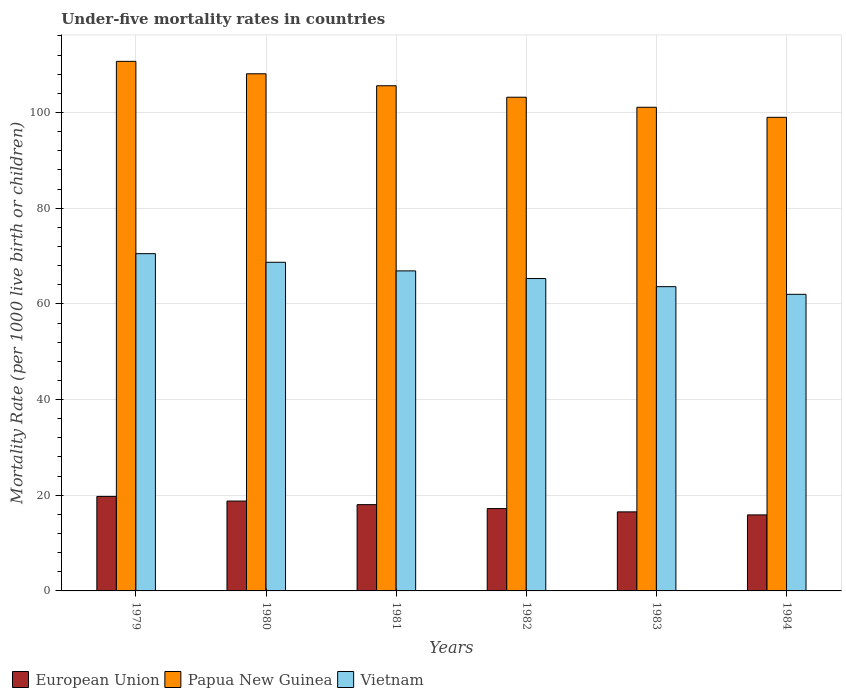Are the number of bars on each tick of the X-axis equal?
Offer a very short reply. Yes. How many bars are there on the 5th tick from the left?
Offer a terse response. 3. How many bars are there on the 1st tick from the right?
Make the answer very short. 3. What is the label of the 1st group of bars from the left?
Give a very brief answer. 1979. In how many cases, is the number of bars for a given year not equal to the number of legend labels?
Your answer should be very brief. 0. What is the under-five mortality rate in Vietnam in 1981?
Make the answer very short. 66.9. Across all years, what is the maximum under-five mortality rate in Papua New Guinea?
Make the answer very short. 110.7. In which year was the under-five mortality rate in European Union maximum?
Your response must be concise. 1979. What is the total under-five mortality rate in European Union in the graph?
Provide a succinct answer. 106.21. What is the difference between the under-five mortality rate in Papua New Guinea in 1979 and that in 1981?
Your answer should be very brief. 5.1. What is the difference between the under-five mortality rate in European Union in 1981 and the under-five mortality rate in Papua New Guinea in 1984?
Offer a terse response. -80.96. What is the average under-five mortality rate in Vietnam per year?
Provide a short and direct response. 66.17. In the year 1979, what is the difference between the under-five mortality rate in Papua New Guinea and under-five mortality rate in Vietnam?
Make the answer very short. 40.2. What is the ratio of the under-five mortality rate in Papua New Guinea in 1982 to that in 1983?
Your answer should be very brief. 1.02. Is the under-five mortality rate in Vietnam in 1983 less than that in 1984?
Your answer should be compact. No. What is the difference between the highest and the second highest under-five mortality rate in European Union?
Your answer should be compact. 0.97. What is the difference between the highest and the lowest under-five mortality rate in Vietnam?
Offer a terse response. 8.5. In how many years, is the under-five mortality rate in European Union greater than the average under-five mortality rate in European Union taken over all years?
Provide a succinct answer. 3. What does the 2nd bar from the left in 1983 represents?
Give a very brief answer. Papua New Guinea. What does the 2nd bar from the right in 1981 represents?
Make the answer very short. Papua New Guinea. How many bars are there?
Make the answer very short. 18. Are all the bars in the graph horizontal?
Your answer should be compact. No. What is the difference between two consecutive major ticks on the Y-axis?
Your response must be concise. 20. Are the values on the major ticks of Y-axis written in scientific E-notation?
Provide a short and direct response. No. Does the graph contain grids?
Ensure brevity in your answer.  Yes. Where does the legend appear in the graph?
Give a very brief answer. Bottom left. What is the title of the graph?
Keep it short and to the point. Under-five mortality rates in countries. Does "Jamaica" appear as one of the legend labels in the graph?
Make the answer very short. No. What is the label or title of the X-axis?
Give a very brief answer. Years. What is the label or title of the Y-axis?
Give a very brief answer. Mortality Rate (per 1000 live birth or children). What is the Mortality Rate (per 1000 live birth or children) in European Union in 1979?
Your response must be concise. 19.76. What is the Mortality Rate (per 1000 live birth or children) in Papua New Guinea in 1979?
Ensure brevity in your answer.  110.7. What is the Mortality Rate (per 1000 live birth or children) in Vietnam in 1979?
Your answer should be very brief. 70.5. What is the Mortality Rate (per 1000 live birth or children) of European Union in 1980?
Keep it short and to the point. 18.78. What is the Mortality Rate (per 1000 live birth or children) in Papua New Guinea in 1980?
Offer a terse response. 108.1. What is the Mortality Rate (per 1000 live birth or children) in Vietnam in 1980?
Keep it short and to the point. 68.7. What is the Mortality Rate (per 1000 live birth or children) in European Union in 1981?
Your answer should be compact. 18.04. What is the Mortality Rate (per 1000 live birth or children) of Papua New Guinea in 1981?
Give a very brief answer. 105.6. What is the Mortality Rate (per 1000 live birth or children) of Vietnam in 1981?
Your answer should be very brief. 66.9. What is the Mortality Rate (per 1000 live birth or children) of European Union in 1982?
Provide a succinct answer. 17.21. What is the Mortality Rate (per 1000 live birth or children) of Papua New Guinea in 1982?
Give a very brief answer. 103.2. What is the Mortality Rate (per 1000 live birth or children) in Vietnam in 1982?
Your answer should be very brief. 65.3. What is the Mortality Rate (per 1000 live birth or children) in European Union in 1983?
Make the answer very short. 16.53. What is the Mortality Rate (per 1000 live birth or children) in Papua New Guinea in 1983?
Ensure brevity in your answer.  101.1. What is the Mortality Rate (per 1000 live birth or children) in Vietnam in 1983?
Give a very brief answer. 63.6. What is the Mortality Rate (per 1000 live birth or children) of European Union in 1984?
Provide a short and direct response. 15.89. Across all years, what is the maximum Mortality Rate (per 1000 live birth or children) in European Union?
Keep it short and to the point. 19.76. Across all years, what is the maximum Mortality Rate (per 1000 live birth or children) in Papua New Guinea?
Keep it short and to the point. 110.7. Across all years, what is the maximum Mortality Rate (per 1000 live birth or children) of Vietnam?
Make the answer very short. 70.5. Across all years, what is the minimum Mortality Rate (per 1000 live birth or children) of European Union?
Your answer should be very brief. 15.89. Across all years, what is the minimum Mortality Rate (per 1000 live birth or children) of Papua New Guinea?
Give a very brief answer. 99. What is the total Mortality Rate (per 1000 live birth or children) in European Union in the graph?
Your answer should be compact. 106.21. What is the total Mortality Rate (per 1000 live birth or children) of Papua New Guinea in the graph?
Offer a terse response. 627.7. What is the total Mortality Rate (per 1000 live birth or children) of Vietnam in the graph?
Give a very brief answer. 397. What is the difference between the Mortality Rate (per 1000 live birth or children) in European Union in 1979 and that in 1980?
Offer a very short reply. 0.97. What is the difference between the Mortality Rate (per 1000 live birth or children) in European Union in 1979 and that in 1981?
Offer a very short reply. 1.72. What is the difference between the Mortality Rate (per 1000 live birth or children) of Papua New Guinea in 1979 and that in 1981?
Offer a terse response. 5.1. What is the difference between the Mortality Rate (per 1000 live birth or children) in European Union in 1979 and that in 1982?
Give a very brief answer. 2.54. What is the difference between the Mortality Rate (per 1000 live birth or children) of Papua New Guinea in 1979 and that in 1982?
Ensure brevity in your answer.  7.5. What is the difference between the Mortality Rate (per 1000 live birth or children) of Vietnam in 1979 and that in 1982?
Provide a succinct answer. 5.2. What is the difference between the Mortality Rate (per 1000 live birth or children) of European Union in 1979 and that in 1983?
Give a very brief answer. 3.23. What is the difference between the Mortality Rate (per 1000 live birth or children) of European Union in 1979 and that in 1984?
Give a very brief answer. 3.86. What is the difference between the Mortality Rate (per 1000 live birth or children) of Papua New Guinea in 1979 and that in 1984?
Offer a very short reply. 11.7. What is the difference between the Mortality Rate (per 1000 live birth or children) of European Union in 1980 and that in 1981?
Give a very brief answer. 0.75. What is the difference between the Mortality Rate (per 1000 live birth or children) in European Union in 1980 and that in 1982?
Offer a terse response. 1.57. What is the difference between the Mortality Rate (per 1000 live birth or children) of Papua New Guinea in 1980 and that in 1982?
Your answer should be compact. 4.9. What is the difference between the Mortality Rate (per 1000 live birth or children) in European Union in 1980 and that in 1983?
Offer a terse response. 2.26. What is the difference between the Mortality Rate (per 1000 live birth or children) in Vietnam in 1980 and that in 1983?
Provide a short and direct response. 5.1. What is the difference between the Mortality Rate (per 1000 live birth or children) of European Union in 1980 and that in 1984?
Your response must be concise. 2.89. What is the difference between the Mortality Rate (per 1000 live birth or children) in Papua New Guinea in 1980 and that in 1984?
Your answer should be compact. 9.1. What is the difference between the Mortality Rate (per 1000 live birth or children) in European Union in 1981 and that in 1982?
Your answer should be compact. 0.83. What is the difference between the Mortality Rate (per 1000 live birth or children) in European Union in 1981 and that in 1983?
Give a very brief answer. 1.51. What is the difference between the Mortality Rate (per 1000 live birth or children) of Vietnam in 1981 and that in 1983?
Ensure brevity in your answer.  3.3. What is the difference between the Mortality Rate (per 1000 live birth or children) of European Union in 1981 and that in 1984?
Ensure brevity in your answer.  2.15. What is the difference between the Mortality Rate (per 1000 live birth or children) in Papua New Guinea in 1981 and that in 1984?
Offer a terse response. 6.6. What is the difference between the Mortality Rate (per 1000 live birth or children) in European Union in 1982 and that in 1983?
Offer a terse response. 0.69. What is the difference between the Mortality Rate (per 1000 live birth or children) of European Union in 1982 and that in 1984?
Your answer should be compact. 1.32. What is the difference between the Mortality Rate (per 1000 live birth or children) of Papua New Guinea in 1982 and that in 1984?
Your answer should be very brief. 4.2. What is the difference between the Mortality Rate (per 1000 live birth or children) in Vietnam in 1982 and that in 1984?
Provide a succinct answer. 3.3. What is the difference between the Mortality Rate (per 1000 live birth or children) of European Union in 1983 and that in 1984?
Offer a terse response. 0.64. What is the difference between the Mortality Rate (per 1000 live birth or children) in Papua New Guinea in 1983 and that in 1984?
Your answer should be very brief. 2.1. What is the difference between the Mortality Rate (per 1000 live birth or children) in European Union in 1979 and the Mortality Rate (per 1000 live birth or children) in Papua New Guinea in 1980?
Make the answer very short. -88.34. What is the difference between the Mortality Rate (per 1000 live birth or children) of European Union in 1979 and the Mortality Rate (per 1000 live birth or children) of Vietnam in 1980?
Make the answer very short. -48.94. What is the difference between the Mortality Rate (per 1000 live birth or children) of European Union in 1979 and the Mortality Rate (per 1000 live birth or children) of Papua New Guinea in 1981?
Make the answer very short. -85.84. What is the difference between the Mortality Rate (per 1000 live birth or children) of European Union in 1979 and the Mortality Rate (per 1000 live birth or children) of Vietnam in 1981?
Your response must be concise. -47.14. What is the difference between the Mortality Rate (per 1000 live birth or children) in Papua New Guinea in 1979 and the Mortality Rate (per 1000 live birth or children) in Vietnam in 1981?
Provide a succinct answer. 43.8. What is the difference between the Mortality Rate (per 1000 live birth or children) of European Union in 1979 and the Mortality Rate (per 1000 live birth or children) of Papua New Guinea in 1982?
Your response must be concise. -83.44. What is the difference between the Mortality Rate (per 1000 live birth or children) in European Union in 1979 and the Mortality Rate (per 1000 live birth or children) in Vietnam in 1982?
Offer a very short reply. -45.54. What is the difference between the Mortality Rate (per 1000 live birth or children) of Papua New Guinea in 1979 and the Mortality Rate (per 1000 live birth or children) of Vietnam in 1982?
Offer a very short reply. 45.4. What is the difference between the Mortality Rate (per 1000 live birth or children) of European Union in 1979 and the Mortality Rate (per 1000 live birth or children) of Papua New Guinea in 1983?
Give a very brief answer. -81.34. What is the difference between the Mortality Rate (per 1000 live birth or children) of European Union in 1979 and the Mortality Rate (per 1000 live birth or children) of Vietnam in 1983?
Your answer should be compact. -43.84. What is the difference between the Mortality Rate (per 1000 live birth or children) of Papua New Guinea in 1979 and the Mortality Rate (per 1000 live birth or children) of Vietnam in 1983?
Provide a succinct answer. 47.1. What is the difference between the Mortality Rate (per 1000 live birth or children) of European Union in 1979 and the Mortality Rate (per 1000 live birth or children) of Papua New Guinea in 1984?
Provide a short and direct response. -79.24. What is the difference between the Mortality Rate (per 1000 live birth or children) of European Union in 1979 and the Mortality Rate (per 1000 live birth or children) of Vietnam in 1984?
Your answer should be very brief. -42.24. What is the difference between the Mortality Rate (per 1000 live birth or children) of Papua New Guinea in 1979 and the Mortality Rate (per 1000 live birth or children) of Vietnam in 1984?
Provide a short and direct response. 48.7. What is the difference between the Mortality Rate (per 1000 live birth or children) in European Union in 1980 and the Mortality Rate (per 1000 live birth or children) in Papua New Guinea in 1981?
Your answer should be very brief. -86.82. What is the difference between the Mortality Rate (per 1000 live birth or children) of European Union in 1980 and the Mortality Rate (per 1000 live birth or children) of Vietnam in 1981?
Your answer should be very brief. -48.12. What is the difference between the Mortality Rate (per 1000 live birth or children) of Papua New Guinea in 1980 and the Mortality Rate (per 1000 live birth or children) of Vietnam in 1981?
Your response must be concise. 41.2. What is the difference between the Mortality Rate (per 1000 live birth or children) of European Union in 1980 and the Mortality Rate (per 1000 live birth or children) of Papua New Guinea in 1982?
Your answer should be compact. -84.42. What is the difference between the Mortality Rate (per 1000 live birth or children) in European Union in 1980 and the Mortality Rate (per 1000 live birth or children) in Vietnam in 1982?
Offer a very short reply. -46.52. What is the difference between the Mortality Rate (per 1000 live birth or children) of Papua New Guinea in 1980 and the Mortality Rate (per 1000 live birth or children) of Vietnam in 1982?
Offer a terse response. 42.8. What is the difference between the Mortality Rate (per 1000 live birth or children) in European Union in 1980 and the Mortality Rate (per 1000 live birth or children) in Papua New Guinea in 1983?
Make the answer very short. -82.32. What is the difference between the Mortality Rate (per 1000 live birth or children) of European Union in 1980 and the Mortality Rate (per 1000 live birth or children) of Vietnam in 1983?
Give a very brief answer. -44.82. What is the difference between the Mortality Rate (per 1000 live birth or children) in Papua New Guinea in 1980 and the Mortality Rate (per 1000 live birth or children) in Vietnam in 1983?
Make the answer very short. 44.5. What is the difference between the Mortality Rate (per 1000 live birth or children) of European Union in 1980 and the Mortality Rate (per 1000 live birth or children) of Papua New Guinea in 1984?
Offer a very short reply. -80.22. What is the difference between the Mortality Rate (per 1000 live birth or children) of European Union in 1980 and the Mortality Rate (per 1000 live birth or children) of Vietnam in 1984?
Provide a succinct answer. -43.22. What is the difference between the Mortality Rate (per 1000 live birth or children) in Papua New Guinea in 1980 and the Mortality Rate (per 1000 live birth or children) in Vietnam in 1984?
Provide a short and direct response. 46.1. What is the difference between the Mortality Rate (per 1000 live birth or children) in European Union in 1981 and the Mortality Rate (per 1000 live birth or children) in Papua New Guinea in 1982?
Your answer should be compact. -85.16. What is the difference between the Mortality Rate (per 1000 live birth or children) of European Union in 1981 and the Mortality Rate (per 1000 live birth or children) of Vietnam in 1982?
Your answer should be compact. -47.26. What is the difference between the Mortality Rate (per 1000 live birth or children) of Papua New Guinea in 1981 and the Mortality Rate (per 1000 live birth or children) of Vietnam in 1982?
Provide a short and direct response. 40.3. What is the difference between the Mortality Rate (per 1000 live birth or children) in European Union in 1981 and the Mortality Rate (per 1000 live birth or children) in Papua New Guinea in 1983?
Make the answer very short. -83.06. What is the difference between the Mortality Rate (per 1000 live birth or children) in European Union in 1981 and the Mortality Rate (per 1000 live birth or children) in Vietnam in 1983?
Your answer should be compact. -45.56. What is the difference between the Mortality Rate (per 1000 live birth or children) in Papua New Guinea in 1981 and the Mortality Rate (per 1000 live birth or children) in Vietnam in 1983?
Your answer should be compact. 42. What is the difference between the Mortality Rate (per 1000 live birth or children) in European Union in 1981 and the Mortality Rate (per 1000 live birth or children) in Papua New Guinea in 1984?
Provide a succinct answer. -80.96. What is the difference between the Mortality Rate (per 1000 live birth or children) of European Union in 1981 and the Mortality Rate (per 1000 live birth or children) of Vietnam in 1984?
Give a very brief answer. -43.96. What is the difference between the Mortality Rate (per 1000 live birth or children) in Papua New Guinea in 1981 and the Mortality Rate (per 1000 live birth or children) in Vietnam in 1984?
Ensure brevity in your answer.  43.6. What is the difference between the Mortality Rate (per 1000 live birth or children) in European Union in 1982 and the Mortality Rate (per 1000 live birth or children) in Papua New Guinea in 1983?
Your answer should be very brief. -83.89. What is the difference between the Mortality Rate (per 1000 live birth or children) in European Union in 1982 and the Mortality Rate (per 1000 live birth or children) in Vietnam in 1983?
Offer a very short reply. -46.39. What is the difference between the Mortality Rate (per 1000 live birth or children) of Papua New Guinea in 1982 and the Mortality Rate (per 1000 live birth or children) of Vietnam in 1983?
Keep it short and to the point. 39.6. What is the difference between the Mortality Rate (per 1000 live birth or children) in European Union in 1982 and the Mortality Rate (per 1000 live birth or children) in Papua New Guinea in 1984?
Provide a succinct answer. -81.79. What is the difference between the Mortality Rate (per 1000 live birth or children) in European Union in 1982 and the Mortality Rate (per 1000 live birth or children) in Vietnam in 1984?
Offer a very short reply. -44.79. What is the difference between the Mortality Rate (per 1000 live birth or children) in Papua New Guinea in 1982 and the Mortality Rate (per 1000 live birth or children) in Vietnam in 1984?
Offer a very short reply. 41.2. What is the difference between the Mortality Rate (per 1000 live birth or children) in European Union in 1983 and the Mortality Rate (per 1000 live birth or children) in Papua New Guinea in 1984?
Give a very brief answer. -82.47. What is the difference between the Mortality Rate (per 1000 live birth or children) of European Union in 1983 and the Mortality Rate (per 1000 live birth or children) of Vietnam in 1984?
Make the answer very short. -45.47. What is the difference between the Mortality Rate (per 1000 live birth or children) in Papua New Guinea in 1983 and the Mortality Rate (per 1000 live birth or children) in Vietnam in 1984?
Your answer should be very brief. 39.1. What is the average Mortality Rate (per 1000 live birth or children) in European Union per year?
Provide a short and direct response. 17.7. What is the average Mortality Rate (per 1000 live birth or children) of Papua New Guinea per year?
Offer a very short reply. 104.62. What is the average Mortality Rate (per 1000 live birth or children) of Vietnam per year?
Your answer should be compact. 66.17. In the year 1979, what is the difference between the Mortality Rate (per 1000 live birth or children) in European Union and Mortality Rate (per 1000 live birth or children) in Papua New Guinea?
Make the answer very short. -90.94. In the year 1979, what is the difference between the Mortality Rate (per 1000 live birth or children) in European Union and Mortality Rate (per 1000 live birth or children) in Vietnam?
Give a very brief answer. -50.74. In the year 1979, what is the difference between the Mortality Rate (per 1000 live birth or children) of Papua New Guinea and Mortality Rate (per 1000 live birth or children) of Vietnam?
Make the answer very short. 40.2. In the year 1980, what is the difference between the Mortality Rate (per 1000 live birth or children) in European Union and Mortality Rate (per 1000 live birth or children) in Papua New Guinea?
Provide a short and direct response. -89.32. In the year 1980, what is the difference between the Mortality Rate (per 1000 live birth or children) in European Union and Mortality Rate (per 1000 live birth or children) in Vietnam?
Keep it short and to the point. -49.92. In the year 1980, what is the difference between the Mortality Rate (per 1000 live birth or children) of Papua New Guinea and Mortality Rate (per 1000 live birth or children) of Vietnam?
Your answer should be very brief. 39.4. In the year 1981, what is the difference between the Mortality Rate (per 1000 live birth or children) in European Union and Mortality Rate (per 1000 live birth or children) in Papua New Guinea?
Offer a terse response. -87.56. In the year 1981, what is the difference between the Mortality Rate (per 1000 live birth or children) in European Union and Mortality Rate (per 1000 live birth or children) in Vietnam?
Make the answer very short. -48.86. In the year 1981, what is the difference between the Mortality Rate (per 1000 live birth or children) of Papua New Guinea and Mortality Rate (per 1000 live birth or children) of Vietnam?
Provide a short and direct response. 38.7. In the year 1982, what is the difference between the Mortality Rate (per 1000 live birth or children) in European Union and Mortality Rate (per 1000 live birth or children) in Papua New Guinea?
Your answer should be compact. -85.99. In the year 1982, what is the difference between the Mortality Rate (per 1000 live birth or children) in European Union and Mortality Rate (per 1000 live birth or children) in Vietnam?
Provide a short and direct response. -48.09. In the year 1982, what is the difference between the Mortality Rate (per 1000 live birth or children) in Papua New Guinea and Mortality Rate (per 1000 live birth or children) in Vietnam?
Keep it short and to the point. 37.9. In the year 1983, what is the difference between the Mortality Rate (per 1000 live birth or children) in European Union and Mortality Rate (per 1000 live birth or children) in Papua New Guinea?
Offer a very short reply. -84.57. In the year 1983, what is the difference between the Mortality Rate (per 1000 live birth or children) of European Union and Mortality Rate (per 1000 live birth or children) of Vietnam?
Keep it short and to the point. -47.07. In the year 1983, what is the difference between the Mortality Rate (per 1000 live birth or children) of Papua New Guinea and Mortality Rate (per 1000 live birth or children) of Vietnam?
Your answer should be compact. 37.5. In the year 1984, what is the difference between the Mortality Rate (per 1000 live birth or children) in European Union and Mortality Rate (per 1000 live birth or children) in Papua New Guinea?
Keep it short and to the point. -83.11. In the year 1984, what is the difference between the Mortality Rate (per 1000 live birth or children) in European Union and Mortality Rate (per 1000 live birth or children) in Vietnam?
Ensure brevity in your answer.  -46.11. What is the ratio of the Mortality Rate (per 1000 live birth or children) in European Union in 1979 to that in 1980?
Provide a short and direct response. 1.05. What is the ratio of the Mortality Rate (per 1000 live birth or children) in Papua New Guinea in 1979 to that in 1980?
Your response must be concise. 1.02. What is the ratio of the Mortality Rate (per 1000 live birth or children) of Vietnam in 1979 to that in 1980?
Make the answer very short. 1.03. What is the ratio of the Mortality Rate (per 1000 live birth or children) of European Union in 1979 to that in 1981?
Offer a very short reply. 1.1. What is the ratio of the Mortality Rate (per 1000 live birth or children) in Papua New Guinea in 1979 to that in 1981?
Ensure brevity in your answer.  1.05. What is the ratio of the Mortality Rate (per 1000 live birth or children) in Vietnam in 1979 to that in 1981?
Your response must be concise. 1.05. What is the ratio of the Mortality Rate (per 1000 live birth or children) of European Union in 1979 to that in 1982?
Offer a terse response. 1.15. What is the ratio of the Mortality Rate (per 1000 live birth or children) in Papua New Guinea in 1979 to that in 1982?
Provide a short and direct response. 1.07. What is the ratio of the Mortality Rate (per 1000 live birth or children) in Vietnam in 1979 to that in 1982?
Keep it short and to the point. 1.08. What is the ratio of the Mortality Rate (per 1000 live birth or children) in European Union in 1979 to that in 1983?
Your answer should be very brief. 1.2. What is the ratio of the Mortality Rate (per 1000 live birth or children) of Papua New Guinea in 1979 to that in 1983?
Provide a short and direct response. 1.09. What is the ratio of the Mortality Rate (per 1000 live birth or children) in Vietnam in 1979 to that in 1983?
Offer a terse response. 1.11. What is the ratio of the Mortality Rate (per 1000 live birth or children) in European Union in 1979 to that in 1984?
Give a very brief answer. 1.24. What is the ratio of the Mortality Rate (per 1000 live birth or children) in Papua New Guinea in 1979 to that in 1984?
Offer a very short reply. 1.12. What is the ratio of the Mortality Rate (per 1000 live birth or children) of Vietnam in 1979 to that in 1984?
Your response must be concise. 1.14. What is the ratio of the Mortality Rate (per 1000 live birth or children) in European Union in 1980 to that in 1981?
Your answer should be very brief. 1.04. What is the ratio of the Mortality Rate (per 1000 live birth or children) of Papua New Guinea in 1980 to that in 1981?
Your answer should be very brief. 1.02. What is the ratio of the Mortality Rate (per 1000 live birth or children) in Vietnam in 1980 to that in 1981?
Give a very brief answer. 1.03. What is the ratio of the Mortality Rate (per 1000 live birth or children) of European Union in 1980 to that in 1982?
Ensure brevity in your answer.  1.09. What is the ratio of the Mortality Rate (per 1000 live birth or children) in Papua New Guinea in 1980 to that in 1982?
Provide a short and direct response. 1.05. What is the ratio of the Mortality Rate (per 1000 live birth or children) in Vietnam in 1980 to that in 1982?
Offer a terse response. 1.05. What is the ratio of the Mortality Rate (per 1000 live birth or children) in European Union in 1980 to that in 1983?
Your answer should be compact. 1.14. What is the ratio of the Mortality Rate (per 1000 live birth or children) of Papua New Guinea in 1980 to that in 1983?
Give a very brief answer. 1.07. What is the ratio of the Mortality Rate (per 1000 live birth or children) of Vietnam in 1980 to that in 1983?
Make the answer very short. 1.08. What is the ratio of the Mortality Rate (per 1000 live birth or children) in European Union in 1980 to that in 1984?
Your response must be concise. 1.18. What is the ratio of the Mortality Rate (per 1000 live birth or children) of Papua New Guinea in 1980 to that in 1984?
Your answer should be very brief. 1.09. What is the ratio of the Mortality Rate (per 1000 live birth or children) in Vietnam in 1980 to that in 1984?
Keep it short and to the point. 1.11. What is the ratio of the Mortality Rate (per 1000 live birth or children) in European Union in 1981 to that in 1982?
Your answer should be very brief. 1.05. What is the ratio of the Mortality Rate (per 1000 live birth or children) in Papua New Guinea in 1981 to that in 1982?
Provide a short and direct response. 1.02. What is the ratio of the Mortality Rate (per 1000 live birth or children) of Vietnam in 1981 to that in 1982?
Your response must be concise. 1.02. What is the ratio of the Mortality Rate (per 1000 live birth or children) of European Union in 1981 to that in 1983?
Ensure brevity in your answer.  1.09. What is the ratio of the Mortality Rate (per 1000 live birth or children) in Papua New Guinea in 1981 to that in 1983?
Ensure brevity in your answer.  1.04. What is the ratio of the Mortality Rate (per 1000 live birth or children) of Vietnam in 1981 to that in 1983?
Your answer should be very brief. 1.05. What is the ratio of the Mortality Rate (per 1000 live birth or children) of European Union in 1981 to that in 1984?
Give a very brief answer. 1.14. What is the ratio of the Mortality Rate (per 1000 live birth or children) of Papua New Guinea in 1981 to that in 1984?
Ensure brevity in your answer.  1.07. What is the ratio of the Mortality Rate (per 1000 live birth or children) of Vietnam in 1981 to that in 1984?
Offer a terse response. 1.08. What is the ratio of the Mortality Rate (per 1000 live birth or children) in European Union in 1982 to that in 1983?
Your answer should be compact. 1.04. What is the ratio of the Mortality Rate (per 1000 live birth or children) of Papua New Guinea in 1982 to that in 1983?
Your answer should be very brief. 1.02. What is the ratio of the Mortality Rate (per 1000 live birth or children) in Vietnam in 1982 to that in 1983?
Your answer should be very brief. 1.03. What is the ratio of the Mortality Rate (per 1000 live birth or children) in European Union in 1982 to that in 1984?
Offer a very short reply. 1.08. What is the ratio of the Mortality Rate (per 1000 live birth or children) in Papua New Guinea in 1982 to that in 1984?
Your answer should be compact. 1.04. What is the ratio of the Mortality Rate (per 1000 live birth or children) of Vietnam in 1982 to that in 1984?
Ensure brevity in your answer.  1.05. What is the ratio of the Mortality Rate (per 1000 live birth or children) in European Union in 1983 to that in 1984?
Make the answer very short. 1.04. What is the ratio of the Mortality Rate (per 1000 live birth or children) in Papua New Guinea in 1983 to that in 1984?
Provide a short and direct response. 1.02. What is the ratio of the Mortality Rate (per 1000 live birth or children) in Vietnam in 1983 to that in 1984?
Keep it short and to the point. 1.03. What is the difference between the highest and the second highest Mortality Rate (per 1000 live birth or children) of European Union?
Make the answer very short. 0.97. What is the difference between the highest and the second highest Mortality Rate (per 1000 live birth or children) in Papua New Guinea?
Your answer should be compact. 2.6. What is the difference between the highest and the lowest Mortality Rate (per 1000 live birth or children) of European Union?
Your answer should be very brief. 3.86. What is the difference between the highest and the lowest Mortality Rate (per 1000 live birth or children) of Papua New Guinea?
Your answer should be compact. 11.7. What is the difference between the highest and the lowest Mortality Rate (per 1000 live birth or children) of Vietnam?
Provide a short and direct response. 8.5. 